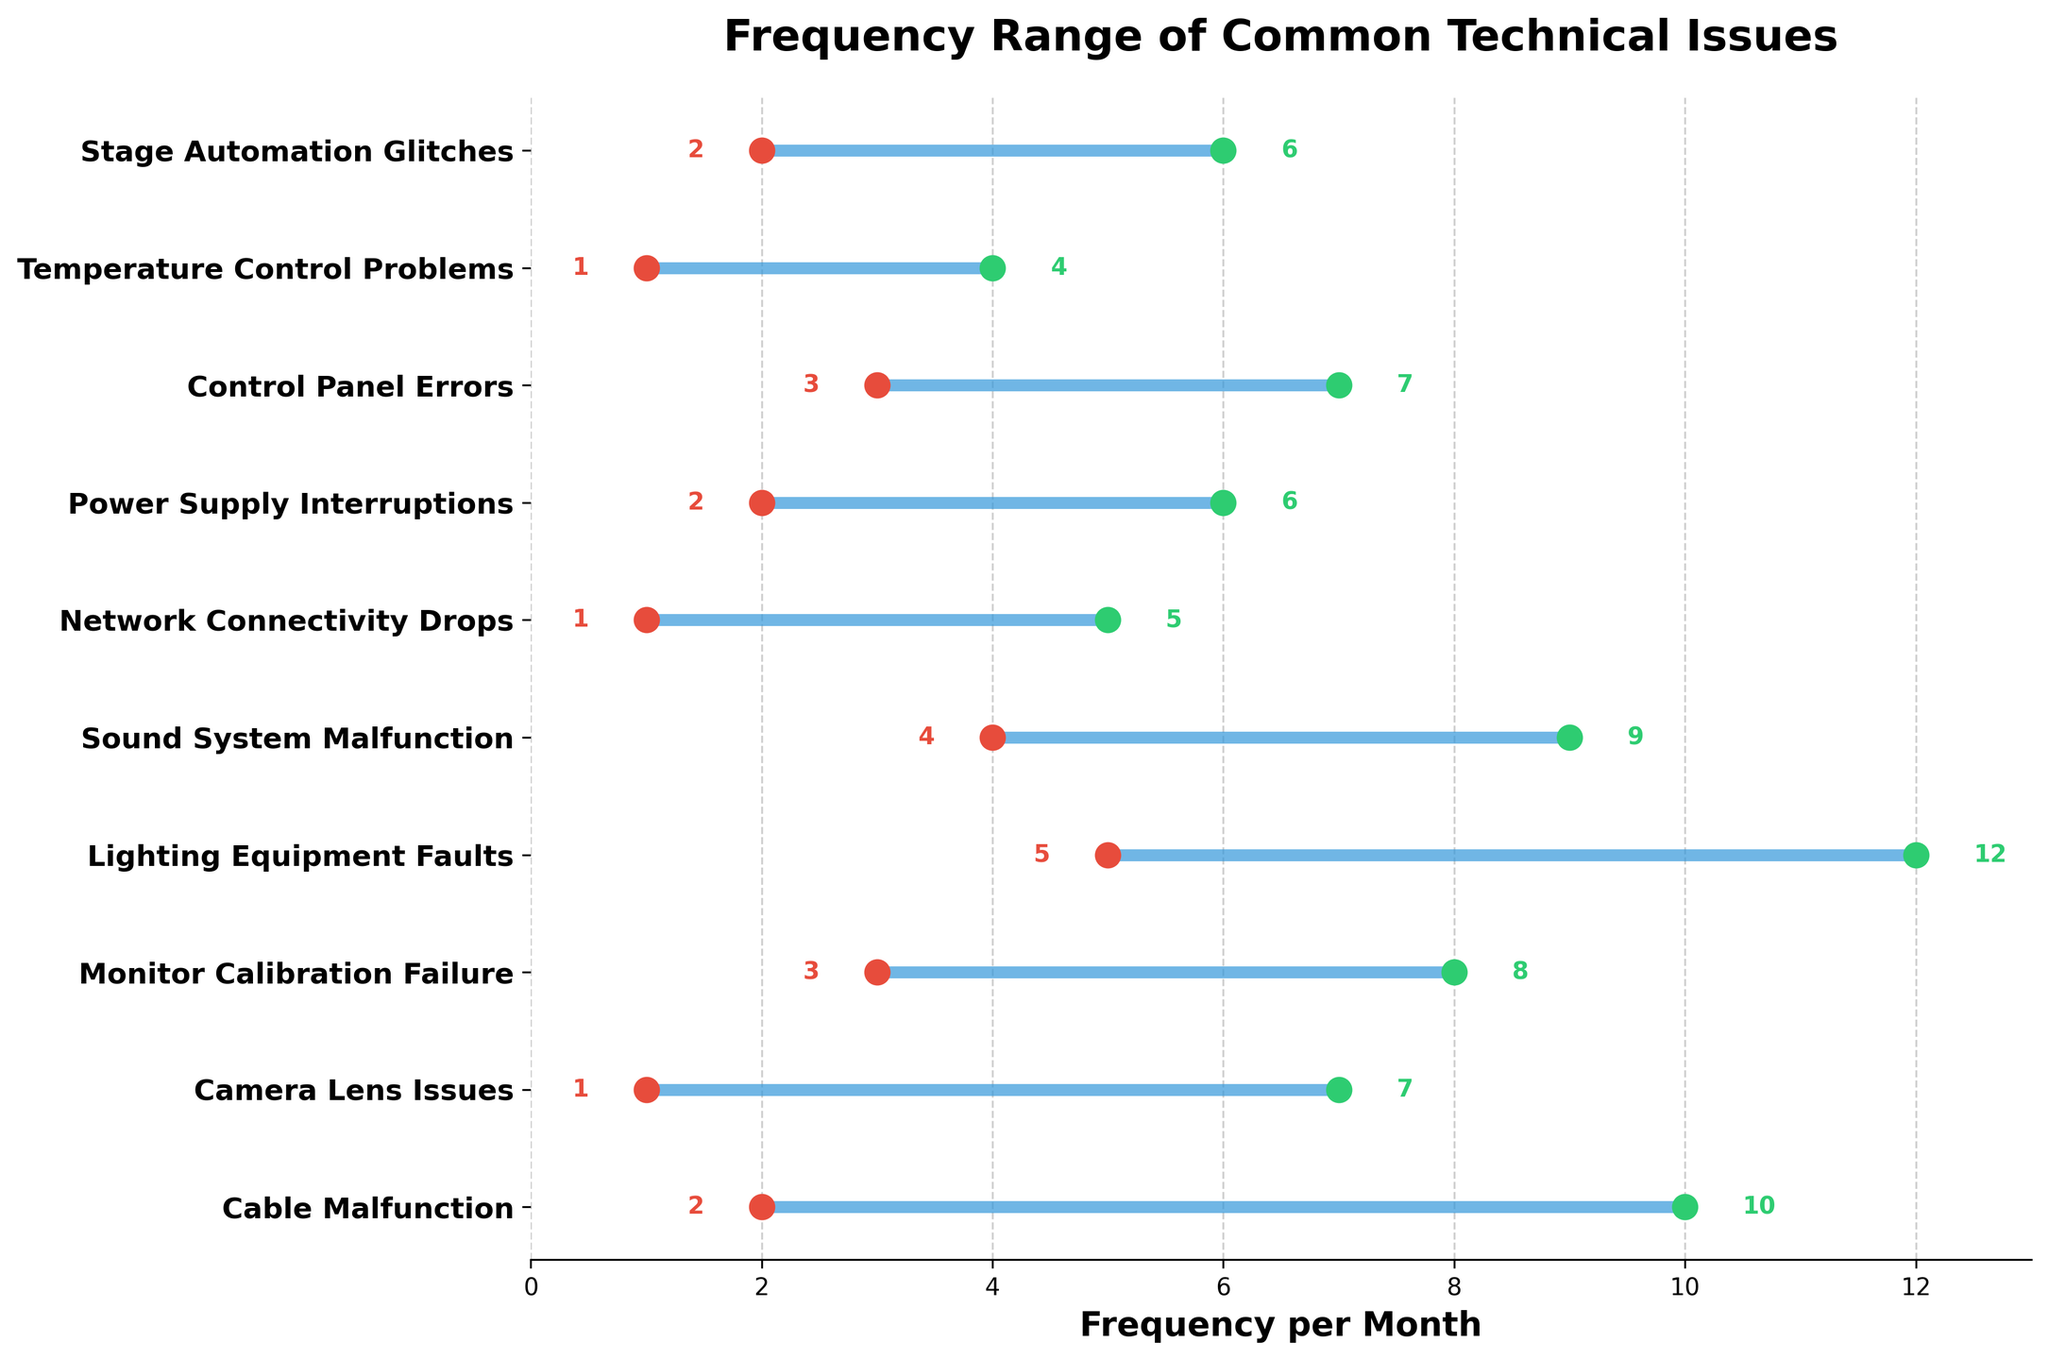How many different technical issues are displayed in the plot? The plot shows 10 different technical issues, as indicated by the 10 labels on the y-axis.
Answer: 10 What is the title of the plot? The title of the plot is displayed at the top and reads "Frequency Range of Common Technical Issues".
Answer: "Frequency Range of Common Technical Issues" Which technical issue has the lowest minimum frequency reported? By looking at the scatter points on the left side of the plot, we can see that the "Camera Lens Issues," "Network Connectivity Drops," and "Temperature Control Problems" all have the lowest minimum frequency of 1.
Answer: Camera Lens Issues, Network Connectivity Drops, Temperature Control Problems What is the frequency range for "Lighting Equipment Faults"? The horizontal line for "Lighting Equipment Faults" starts at 5 and ends at 12, indicating the range.
Answer: 5 to 12 Which technical issues have both a minimum and a maximum frequency of less than 5? Checking the plot, "Camera Lens Issues," "Network Connectivity Drops," and "Temperature Control Problems" satisfy this condition with both minimum and maximum frequencies under 5.
Answer: Camera Lens Issues, Network Connectivity Drops, Temperature Control Problems What is the difference between the maximum and minimum frequencies of "Sound System Malfunction"? The minimum frequency for "Sound System Malfunction" is 4 and the maximum is 9. The difference is 9 - 4.
Answer: 5 Which technical issue has the largest range of frequencies? To find this, we compare the ranges (high - low) for all issues. "Lighting Equipment Faults" has the largest range of 12 - 5 = 7.
Answer: Lighting Equipment Faults What's the average minimum frequency of all technical issues? Add the minimum frequencies (2 + 1 + 3 + 5 + 4 + 1 + 2 + 3 + 1 + 2 = 24) and divide by the number of issues (10). 24 / 10 = 2.4.
Answer: 2.4 Which technical issues have a maximum frequency greater than 10? Checking the plot, the only issue with a maximum frequency above 10 is "Lighting Equipment Faults" with a maximum of 12.
Answer: Lighting Equipment Faults 